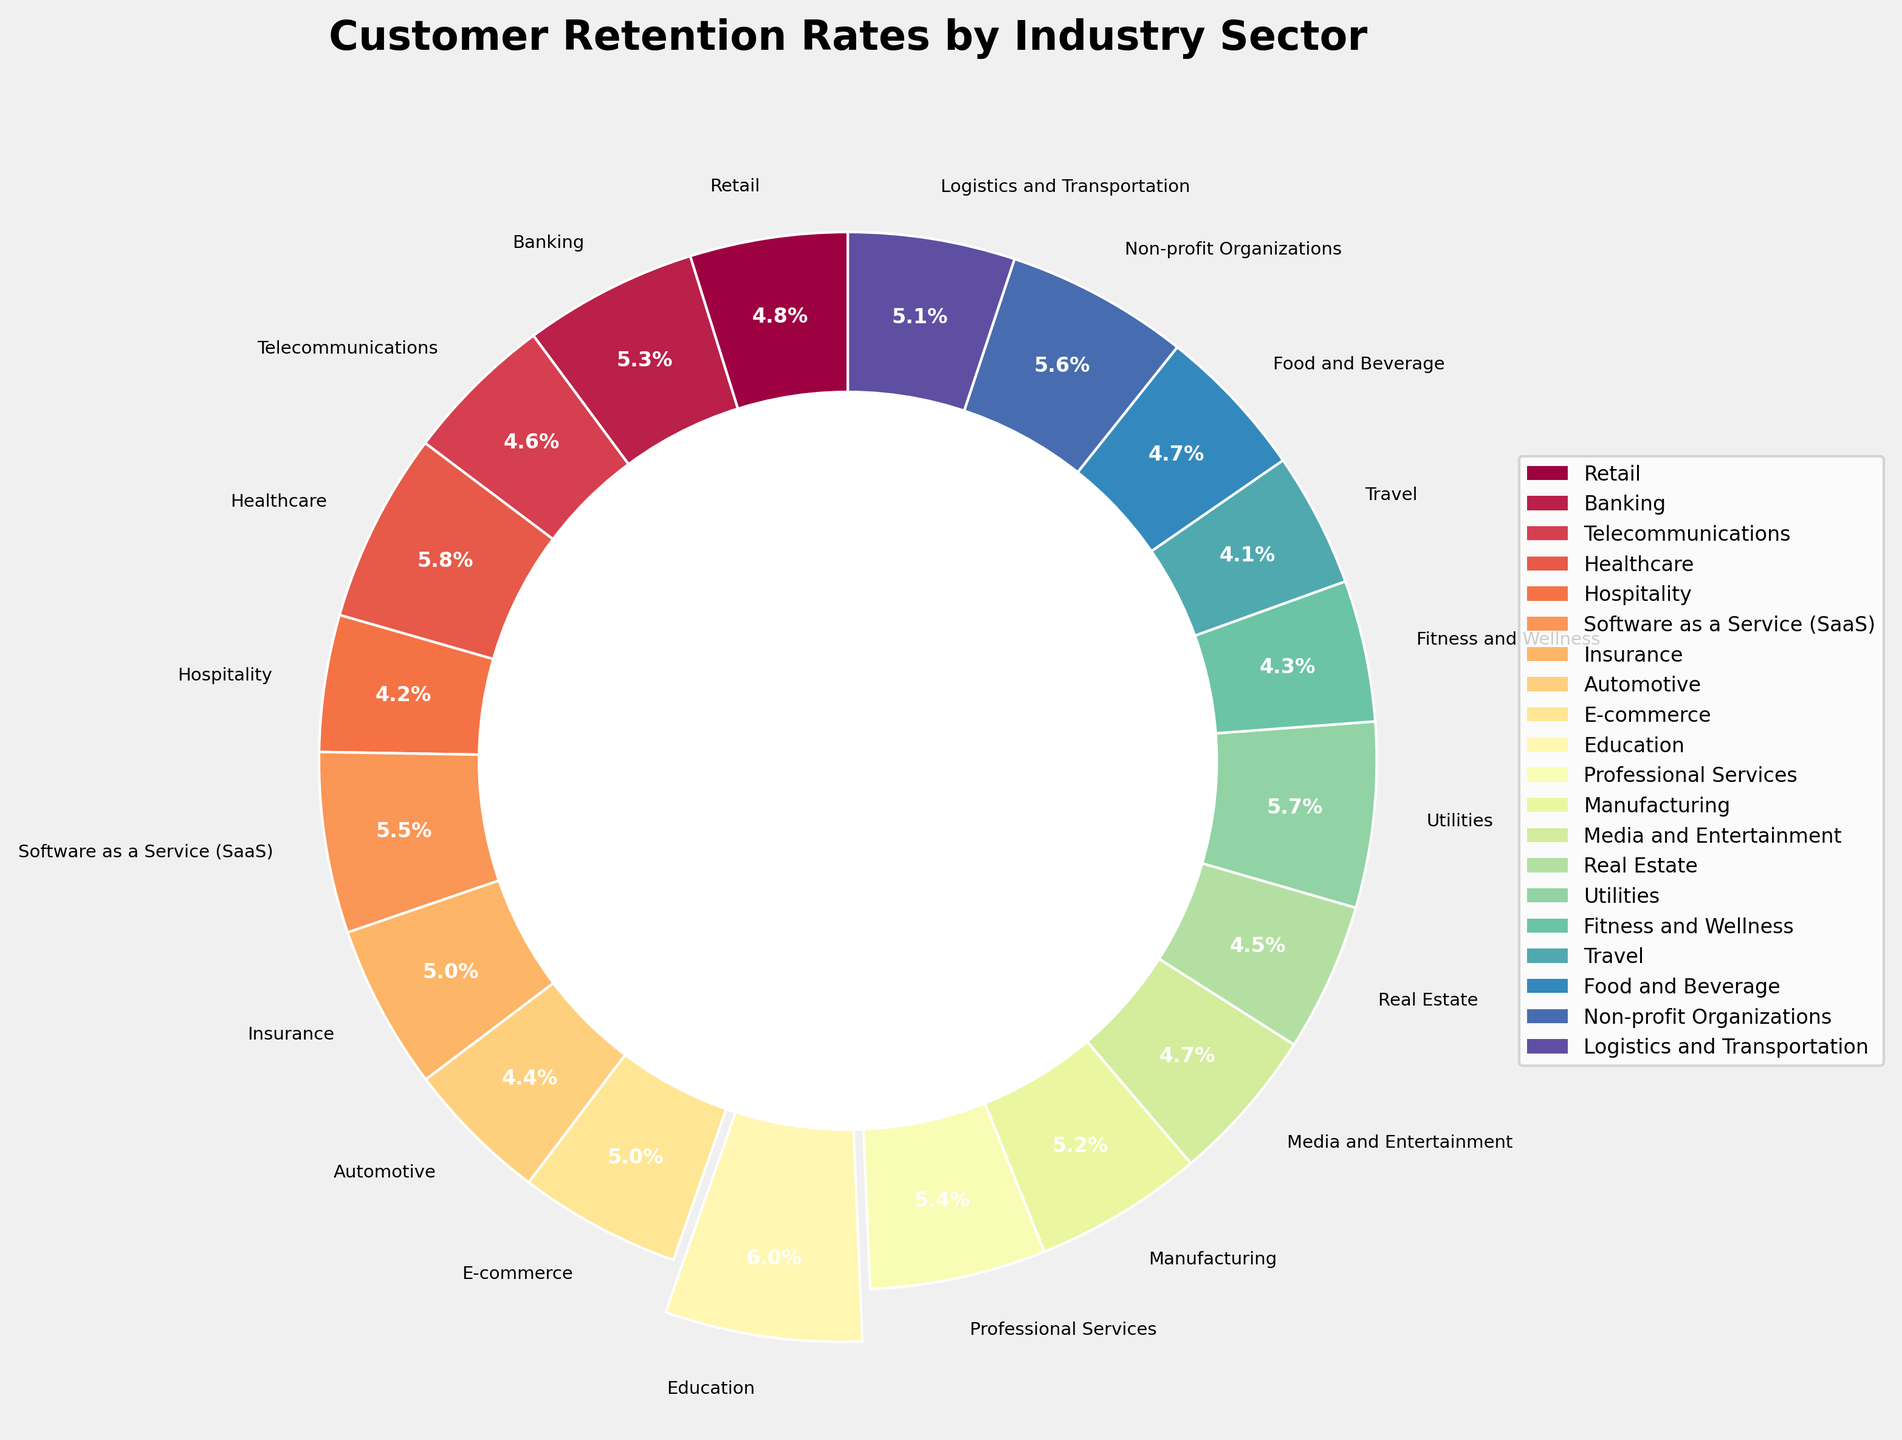Which industry sector has the highest customer retention rate? The healthcare sector has the highest customer retention rate because the pie slice representing "Healthcare" is separated from the rest and labeled with the highest percentage.
Answer: Healthcare Which industry sector has the lowest customer retention rate? The travel sector has the lowest customer retention rate because its pie slice is labeled with the lowest percentage.
Answer: Travel What is the difference in customer retention rates between the highest and lowest sectors? The highest retention rate is in Healthcare (82%) and the lowest is in Travel (58%), so the difference is 82% - 58% = 24%.
Answer: 24% What is the combined customer retention rate of the top three sectors? The top three sectors by retention rates are Education (85%), Healthcare (82%), and Utilities (80%). Combined, their rates are 85% + 82% + 80% = 247%.
Answer: 247% How does the retention rate in the software as a service (SaaS) sector compare to that in the telecommunications sector? The retention rate in the SaaS sector is 78%, while in the telecommunications sector it is 65%. Thus, the SaaS sector has a higher retention rate by 78% - 65% = 13%.
Answer: 13% What is the average customer retention rate across all industry sectors shown? Add all the retention rates together (68 + 75 + 65 + 82 + 59 + 78 + 71 + 62 + 70 + 85 + 76 + 73 + 67 + 64 + 80 + 61 + 58 + 66 + 79 + 72) for a total of 1311 and divide by the number of industry sectors (20). The average is 1311 / 20 = 65.55%.
Answer: 65.55% Which sector falls at the median retention rate, and what is the value? First list the retention rates in ascending order: 58, 59, 61, 62, 64, 65, 66, 67, 68, 70, 71, 72, 73, 75, 76, 78, 79, 80, 82, 85. The median is the average of the 10th and 11th values since there are 20 data points. The 10th and 11th values are 70 and 71, so the median retention rate is (70 + 71) / 2 = 70.5%, with sectors E-Commerce and Insurance falling close to this median.
Answer: 70.5% Compare the sum of retention rates for sectors with rates above 75% to those with rates below 65%. Rates above 75%: Banking (75), Healthcare (82), SaaS (78), Education (85), Professional Services (76), Utilities (80), Non-profit Organizations (79) total 75+82+78+85+76+80+79 = 555%. Rates below 65%: Telecommunications (65), Hospitality (59), Automotive (62), Real Estate (64), Fitness and Wellness (61), Travel (58), Food and Beverage (66) total 65+59+62+64+61+58+66 = 435%.
Answer: 555% vs. 435% What is the percentage contribution of the Retail sector to the overall customer retention rates? The retention rate of the Retail sector is 68%. The total retention rate sum across all sectors is 1311%. Therefore, the contribution percentage is (68 / 1311) * 100% ≈ 5.19%.
Answer: 5.19% 